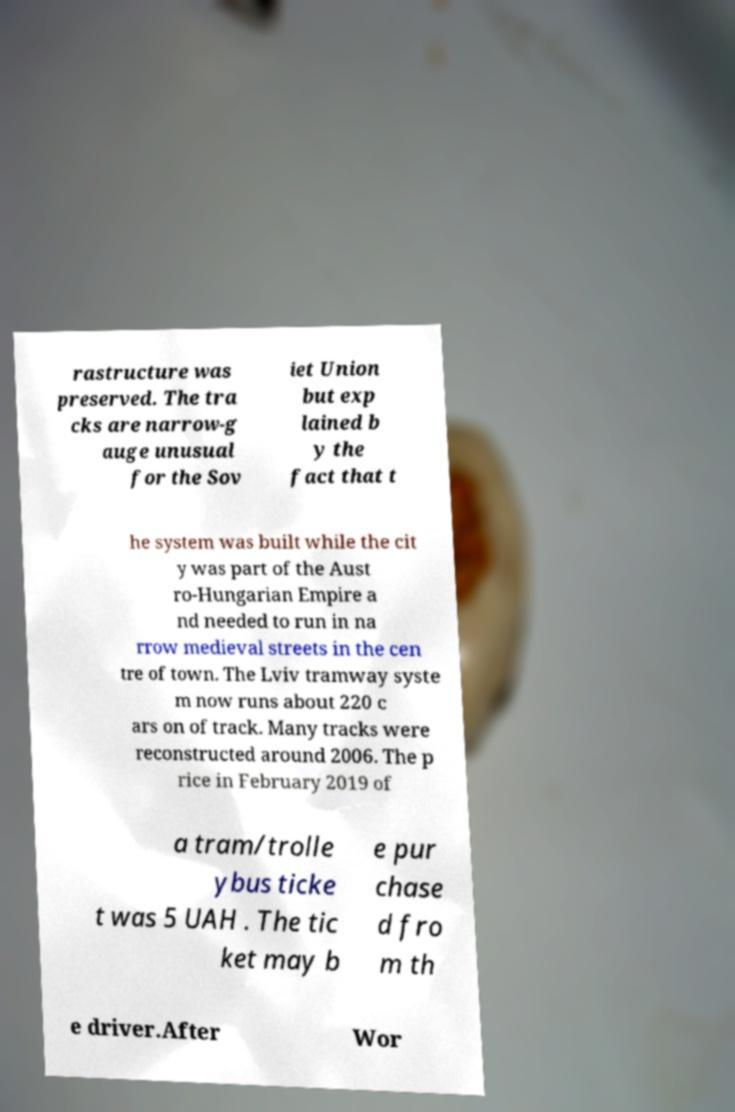Could you extract and type out the text from this image? rastructure was preserved. The tra cks are narrow-g auge unusual for the Sov iet Union but exp lained b y the fact that t he system was built while the cit y was part of the Aust ro-Hungarian Empire a nd needed to run in na rrow medieval streets in the cen tre of town. The Lviv tramway syste m now runs about 220 c ars on of track. Many tracks were reconstructed around 2006. The p rice in February 2019 of a tram/trolle ybus ticke t was 5 UAH . The tic ket may b e pur chase d fro m th e driver.After Wor 